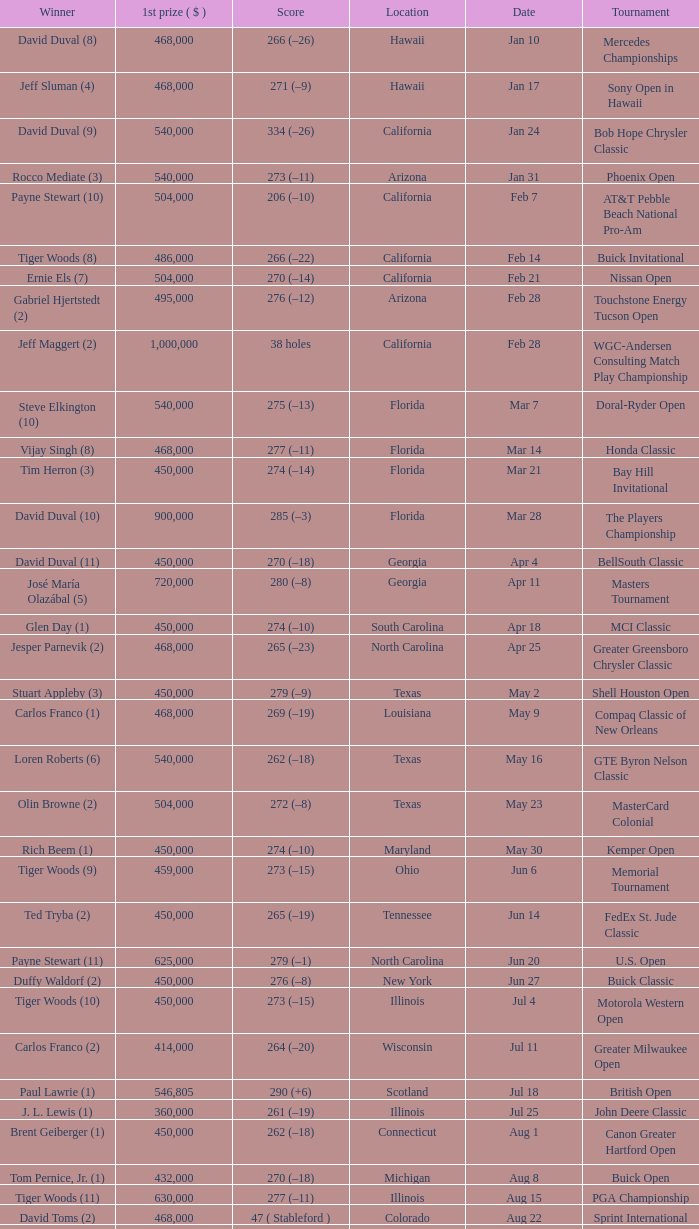What is the date of the Greater Greensboro Chrysler Classic? Apr 25. 